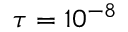<formula> <loc_0><loc_0><loc_500><loc_500>\tau = 1 0 ^ { - 8 }</formula> 